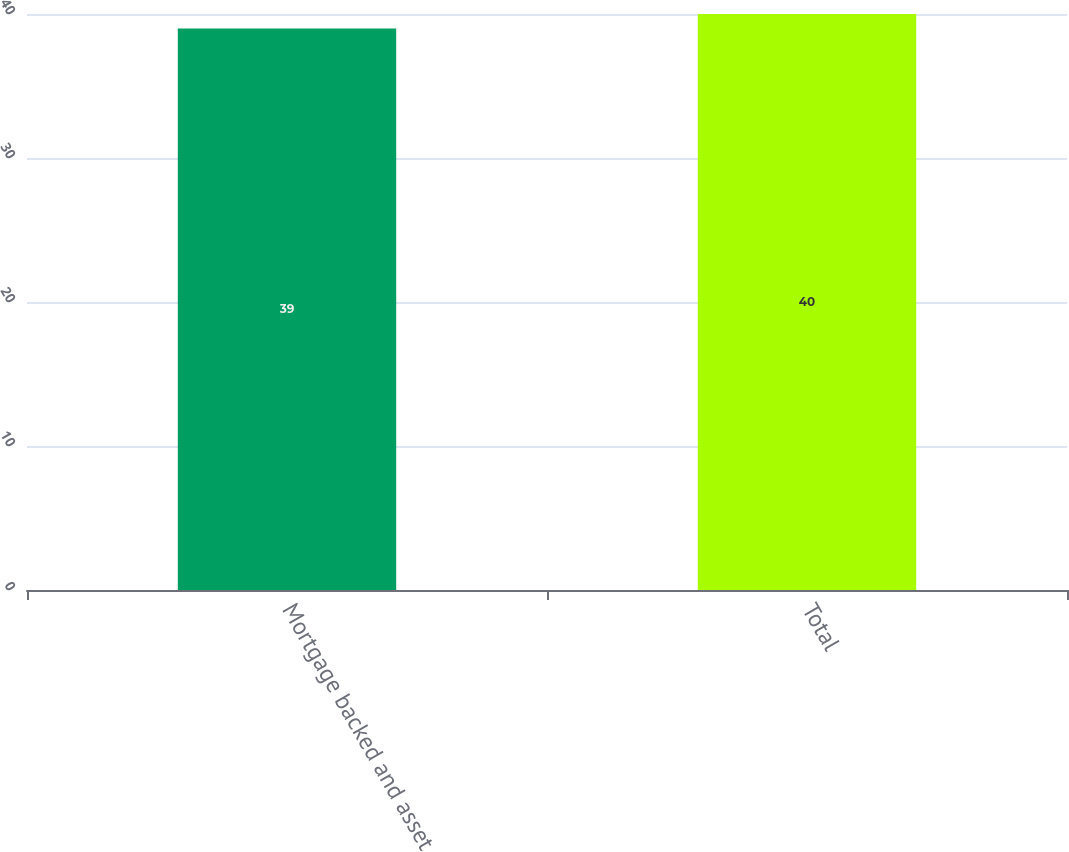Convert chart. <chart><loc_0><loc_0><loc_500><loc_500><bar_chart><fcel>Mortgage backed and asset<fcel>Total<nl><fcel>39<fcel>40<nl></chart> 